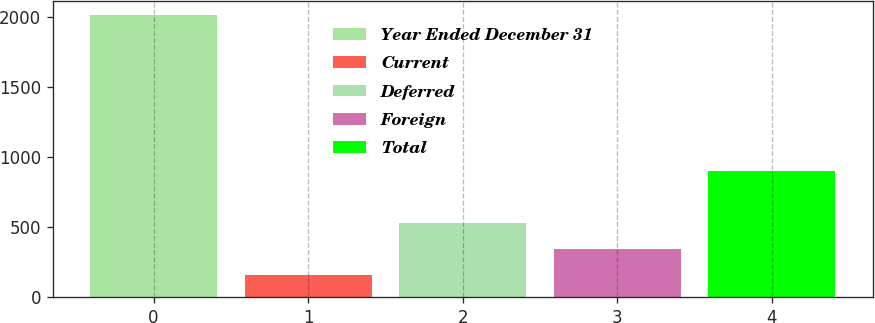Convert chart. <chart><loc_0><loc_0><loc_500><loc_500><bar_chart><fcel>Year Ended December 31<fcel>Current<fcel>Deferred<fcel>Foreign<fcel>Total<nl><fcel>2010<fcel>154<fcel>525.2<fcel>339.6<fcel>895<nl></chart> 